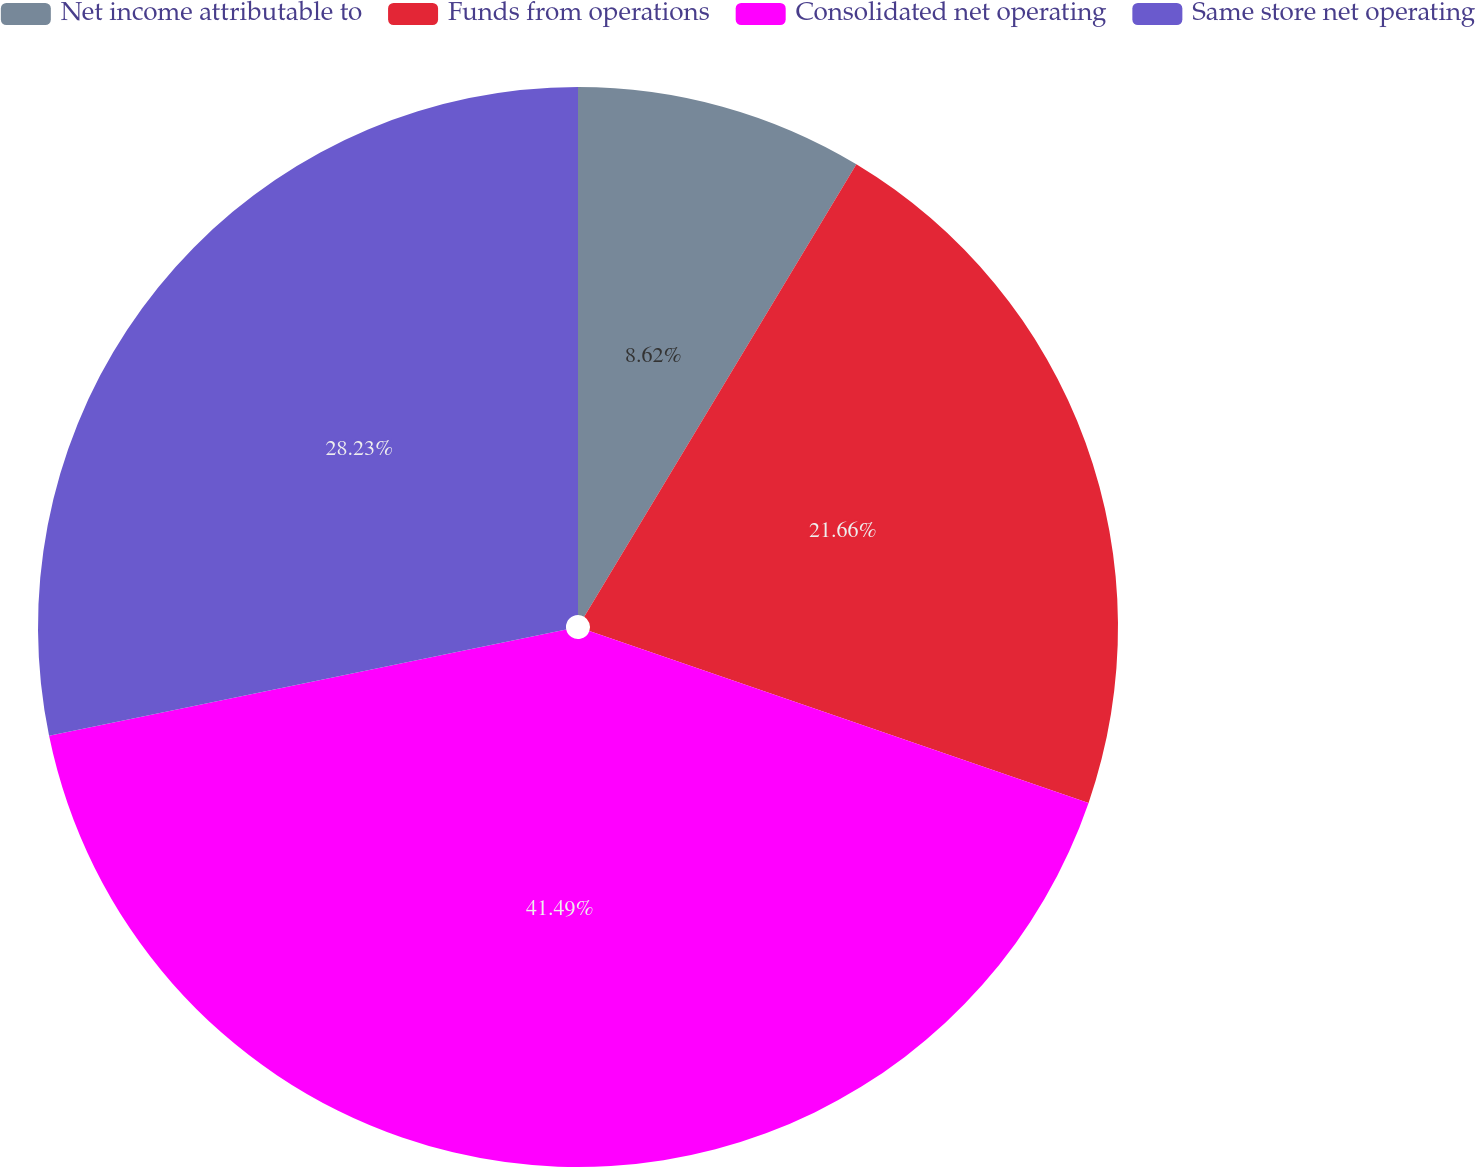<chart> <loc_0><loc_0><loc_500><loc_500><pie_chart><fcel>Net income attributable to<fcel>Funds from operations<fcel>Consolidated net operating<fcel>Same store net operating<nl><fcel>8.62%<fcel>21.66%<fcel>41.49%<fcel>28.23%<nl></chart> 